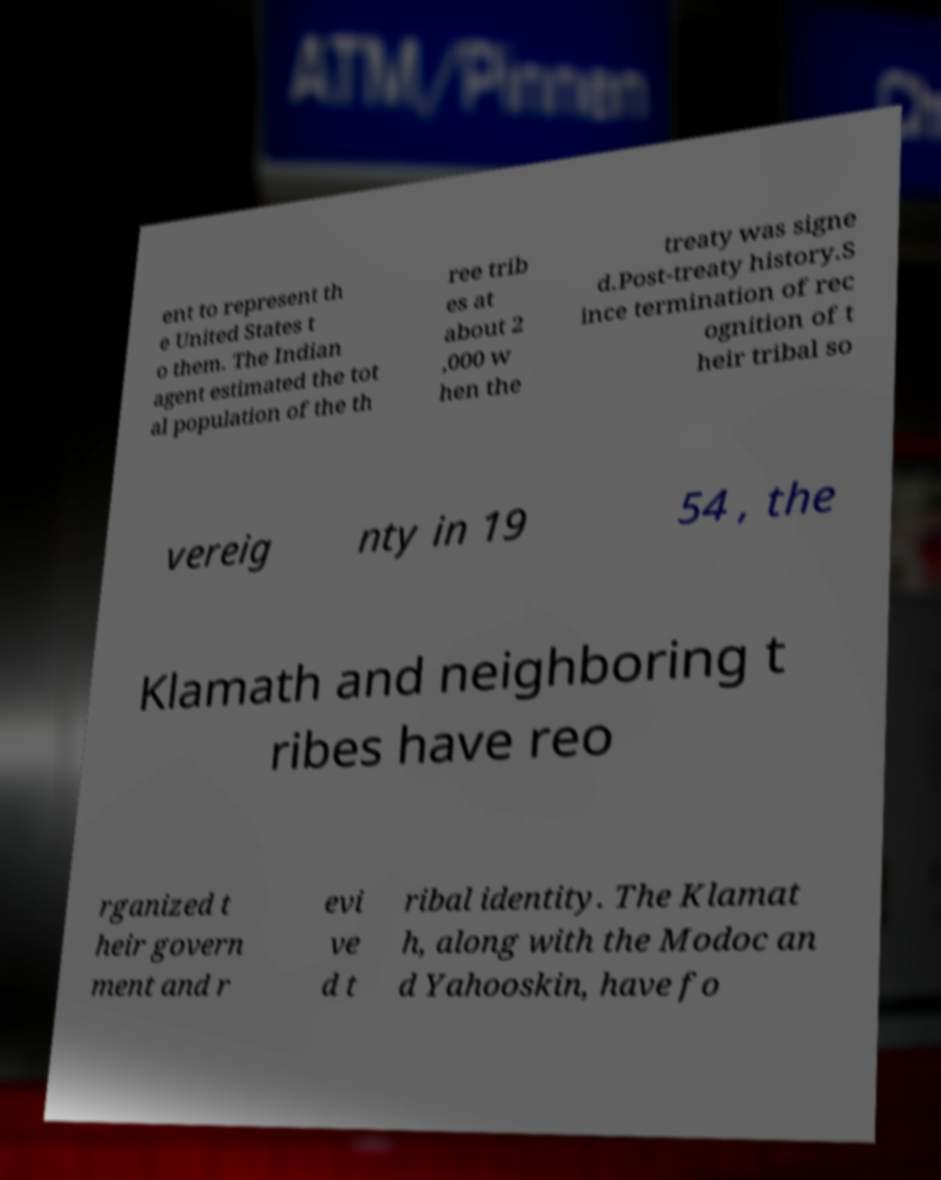Can you accurately transcribe the text from the provided image for me? ent to represent th e United States t o them. The Indian agent estimated the tot al population of the th ree trib es at about 2 ,000 w hen the treaty was signe d.Post-treaty history.S ince termination of rec ognition of t heir tribal so vereig nty in 19 54 , the Klamath and neighboring t ribes have reo rganized t heir govern ment and r evi ve d t ribal identity. The Klamat h, along with the Modoc an d Yahooskin, have fo 